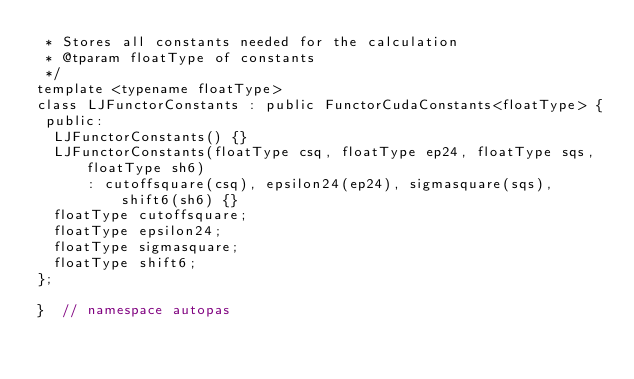<code> <loc_0><loc_0><loc_500><loc_500><_Cuda_> * Stores all constants needed for the calculation
 * @tparam floatType of constants
 */
template <typename floatType>
class LJFunctorConstants : public FunctorCudaConstants<floatType> {
 public:
  LJFunctorConstants() {}
  LJFunctorConstants(floatType csq, floatType ep24, floatType sqs, floatType sh6)
      : cutoffsquare(csq), epsilon24(ep24), sigmasquare(sqs), shift6(sh6) {}
  floatType cutoffsquare;
  floatType epsilon24;
  floatType sigmasquare;
  floatType shift6;
};

}  // namespace autopas</code> 